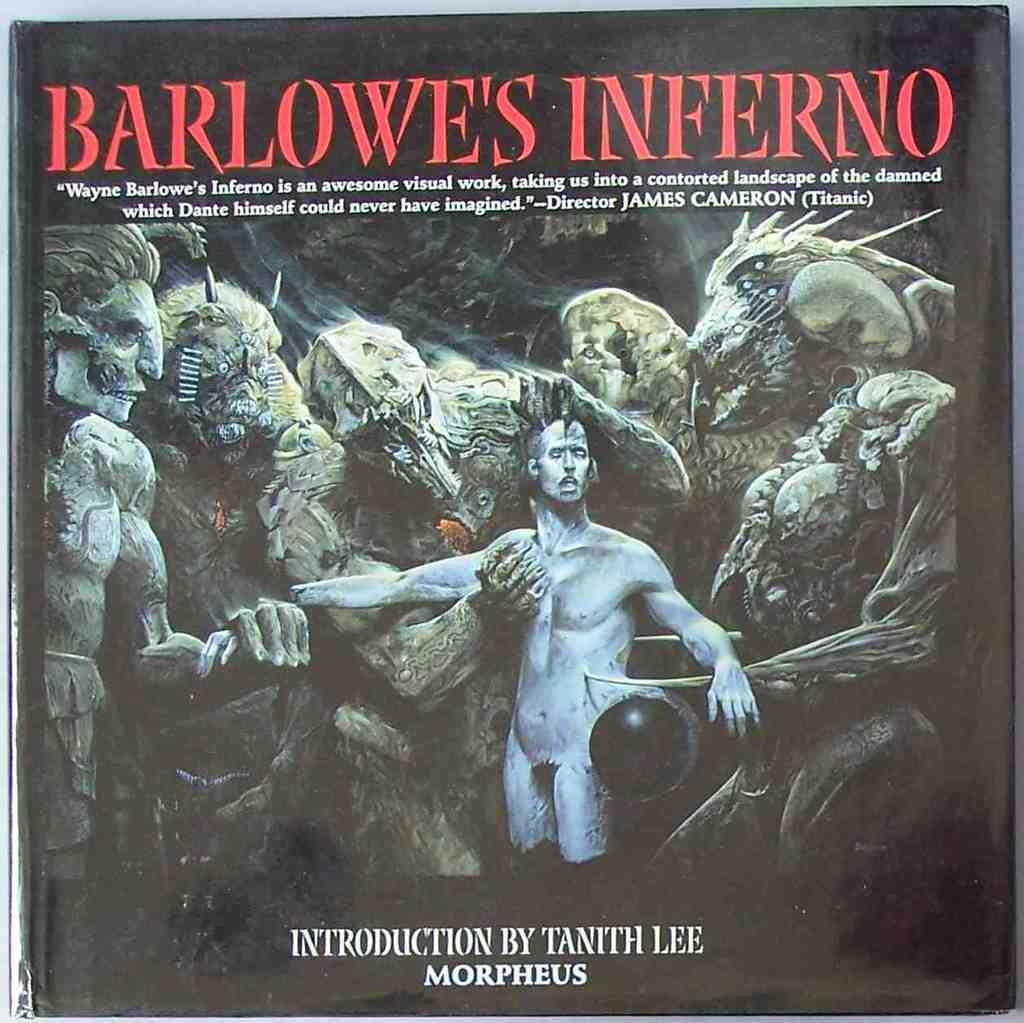What type of visual is shown in the image? The image is a poster. What can be seen in the poster? There are people depicted in the poster. Are there any words or phrases on the poster? Yes, there is text present on the poster. What type of cap is the lumber wearing in the image? There is no cap or lumber present in the image; it features a poster with people and text. Is there a crown visible on any of the people in the image? There is no crown visible on any of the people in the image. 